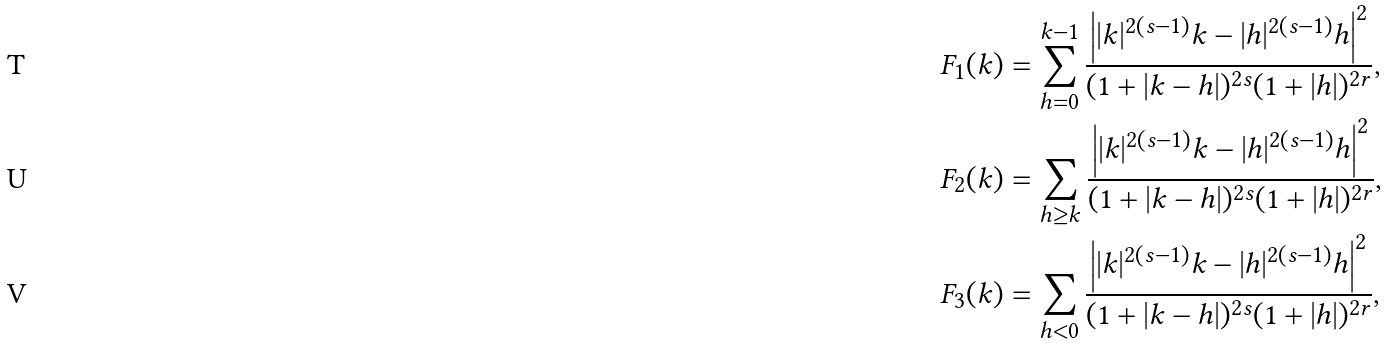Convert formula to latex. <formula><loc_0><loc_0><loc_500><loc_500>F _ { 1 } ( k ) & = \sum _ { h = 0 } ^ { k - 1 } \frac { \left | | k | ^ { 2 ( s - 1 ) } k - | h | ^ { 2 ( s - 1 ) } h \right | ^ { 2 } } { ( 1 + | k - h | ) ^ { 2 s } ( 1 + | h | ) ^ { 2 r } } , \\ F _ { 2 } ( k ) & = \sum _ { h \geq k } \frac { \left | | k | ^ { 2 ( s - 1 ) } k - | h | ^ { 2 ( s - 1 ) } h \right | ^ { 2 } } { ( 1 + | k - h | ) ^ { 2 s } ( 1 + | h | ) ^ { 2 r } } , \\ F _ { 3 } ( k ) & = \sum _ { h < 0 } \frac { \left | | k | ^ { 2 ( s - 1 ) } k - | h | ^ { 2 ( s - 1 ) } h \right | ^ { 2 } } { ( 1 + | k - h | ) ^ { 2 s } ( 1 + | h | ) ^ { 2 r } } ,</formula> 